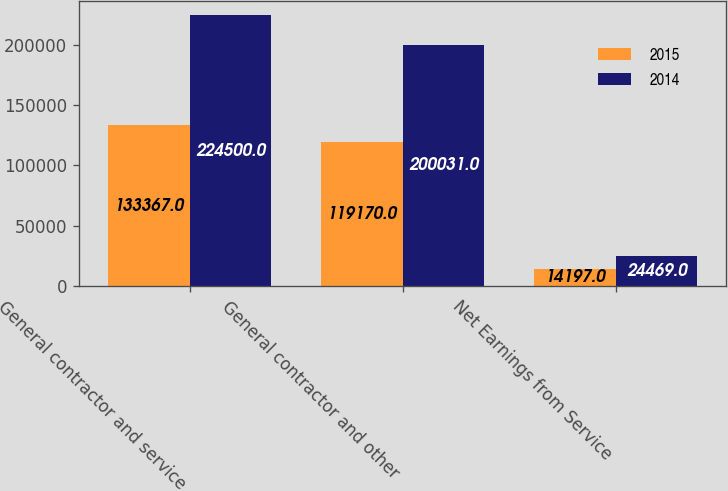<chart> <loc_0><loc_0><loc_500><loc_500><stacked_bar_chart><ecel><fcel>General contractor and service<fcel>General contractor and other<fcel>Net Earnings from Service<nl><fcel>2015<fcel>133367<fcel>119170<fcel>14197<nl><fcel>2014<fcel>224500<fcel>200031<fcel>24469<nl></chart> 